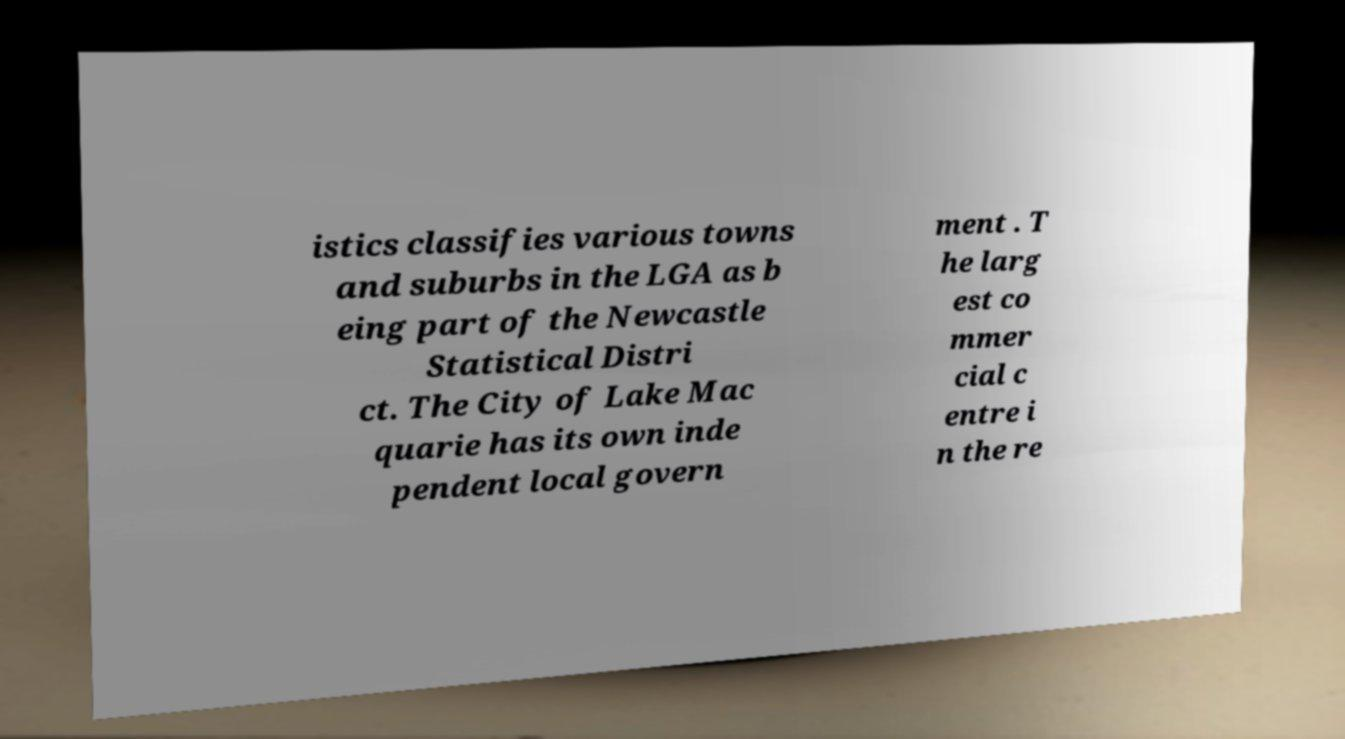Could you assist in decoding the text presented in this image and type it out clearly? istics classifies various towns and suburbs in the LGA as b eing part of the Newcastle Statistical Distri ct. The City of Lake Mac quarie has its own inde pendent local govern ment . T he larg est co mmer cial c entre i n the re 